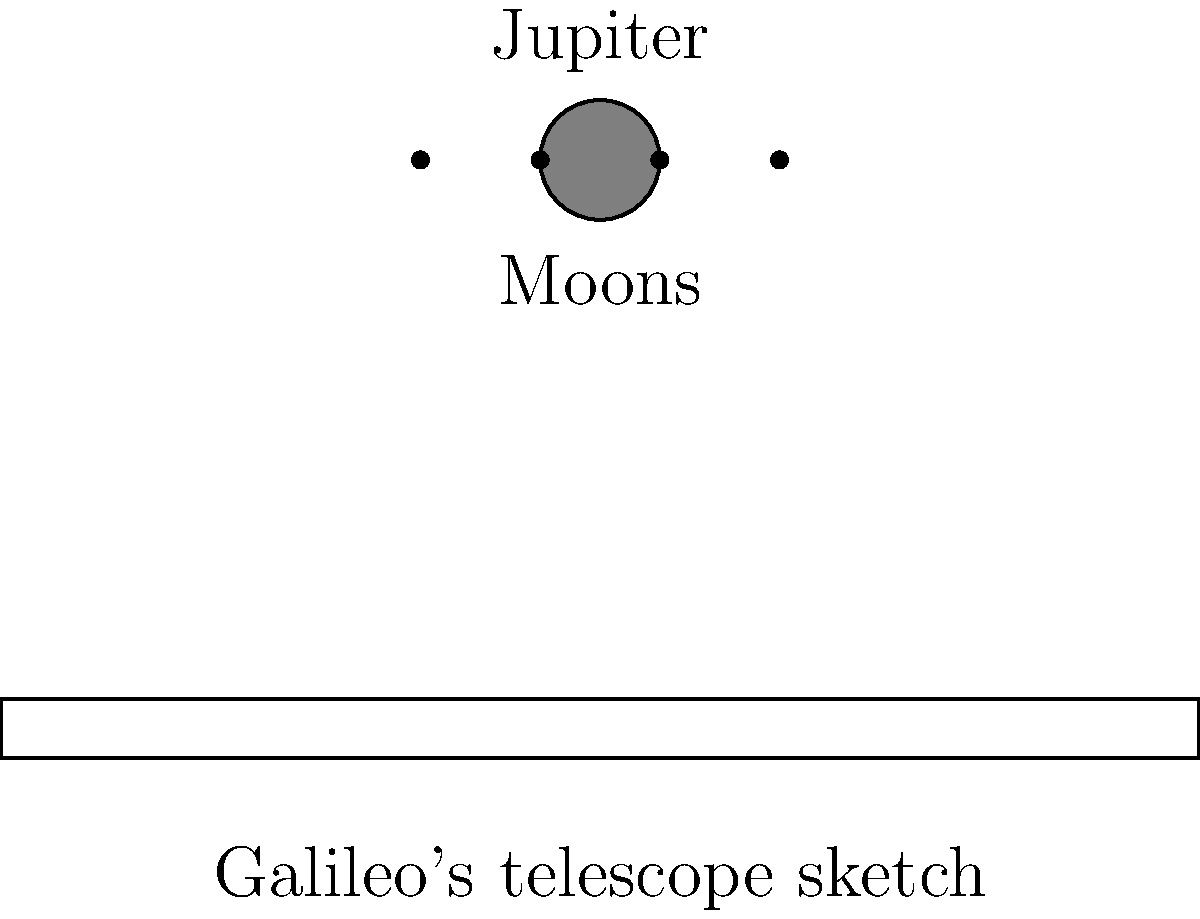What significant discovery did Galileo make about Jupiter using his telescope, as illustrated in the sketch above, and how did this observation challenge the prevailing astronomical beliefs of his time? 1. Galileo's observation: In 1610, Galileo used his improved telescope to observe Jupiter and noticed four small, bright objects near the planet.

2. Tracking the objects: Over several nights, Galileo observed that these objects changed their positions relative to Jupiter but always remained close to the planet.

3. Conclusion: Galileo concluded that these objects were moons orbiting Jupiter. This was the first observation of moons around a planet other than Earth.

4. Significance: This discovery challenged the geocentric model of the universe, which was the prevailing belief at the time.

5. Geocentric model: This model, supported by the Catholic Church and based on ancient Greek astronomy, placed Earth at the center of the universe with all celestial bodies orbiting around it.

6. Challenge to geocentrism: The observation of moons orbiting Jupiter showed that not all celestial bodies orbit Earth, contradicting the geocentric model.

7. Support for heliocentrism: This discovery provided evidence supporting the heliocentric model proposed by Copernicus, which placed the Sun at the center of the solar system.

8. Impact on scientific thought: Galileo's observation helped shift astronomical understanding from a Earth-centered to a Sun-centered view of the solar system, contributing to the Scientific Revolution.
Answer: Galileo discovered four moons orbiting Jupiter, challenging the geocentric model of the universe. 